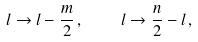Convert formula to latex. <formula><loc_0><loc_0><loc_500><loc_500>l \rightarrow l - \frac { m } { 2 } \, , \quad l \rightarrow \frac { n } { 2 } - l \, ,</formula> 